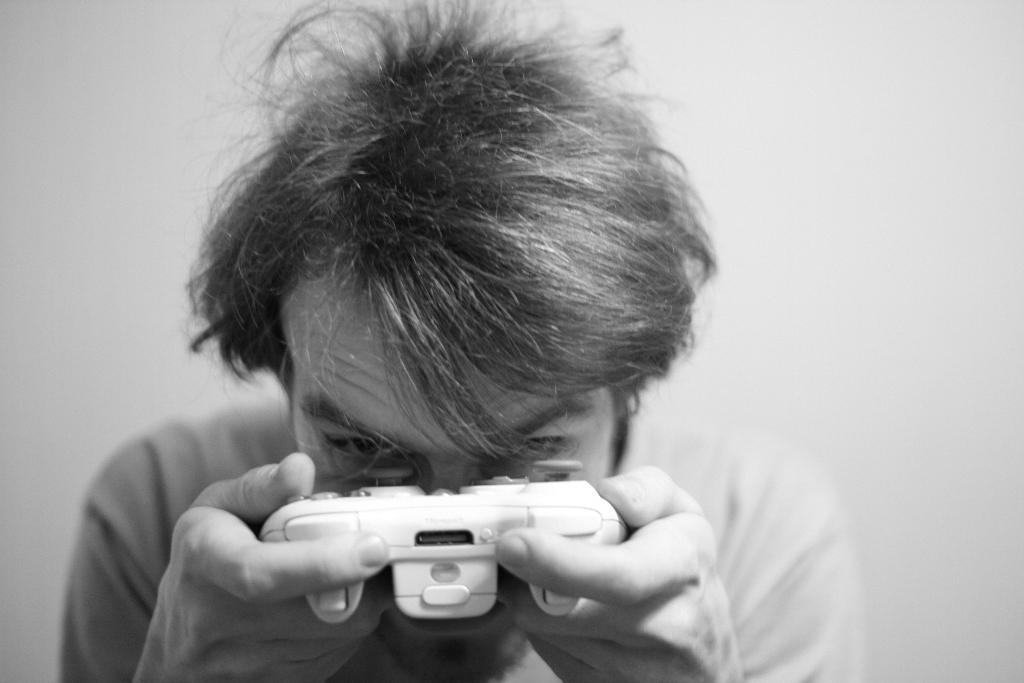What is the color scheme of the image? The image is black and white. What is the main subject of the image? There is a man in the image. What is the man holding in the image? The man is holding a wireless game controller. Can you see any pens in the image? There are no pens visible in the image. Are there any boats in the image? There are no boats present in the image. Is there a parcel being delivered in the image? There is no parcel delivery depicted in the image. 